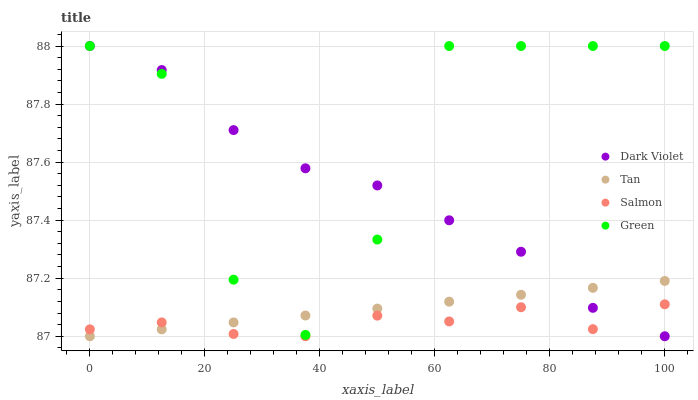Does Salmon have the minimum area under the curve?
Answer yes or no. Yes. Does Green have the maximum area under the curve?
Answer yes or no. Yes. Does Tan have the minimum area under the curve?
Answer yes or no. No. Does Tan have the maximum area under the curve?
Answer yes or no. No. Is Tan the smoothest?
Answer yes or no. Yes. Is Green the roughest?
Answer yes or no. Yes. Is Salmon the smoothest?
Answer yes or no. No. Is Salmon the roughest?
Answer yes or no. No. Does Tan have the lowest value?
Answer yes or no. Yes. Does Dark Violet have the highest value?
Answer yes or no. Yes. Does Tan have the highest value?
Answer yes or no. No. Is Salmon less than Green?
Answer yes or no. Yes. Is Green greater than Salmon?
Answer yes or no. Yes. Does Dark Violet intersect Tan?
Answer yes or no. Yes. Is Dark Violet less than Tan?
Answer yes or no. No. Is Dark Violet greater than Tan?
Answer yes or no. No. Does Salmon intersect Green?
Answer yes or no. No. 